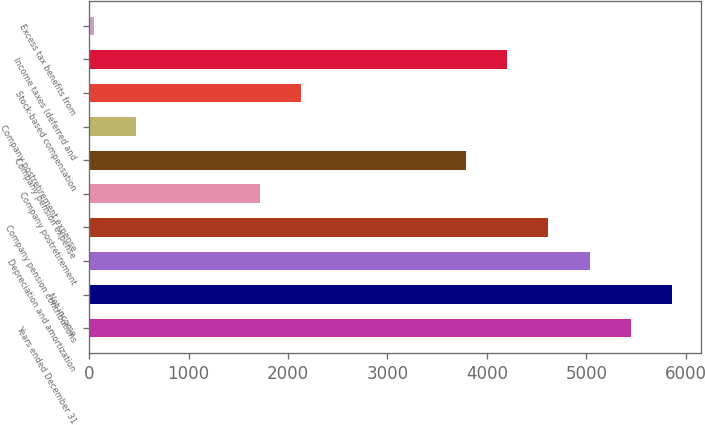Convert chart. <chart><loc_0><loc_0><loc_500><loc_500><bar_chart><fcel>Years ended December 31<fcel>Net income<fcel>Depreciation and amortization<fcel>Company pension contributions<fcel>Company postretirement<fcel>Company pension expense<fcel>Company postretirement expense<fcel>Stock-based compensation<fcel>Income taxes (deferred and<fcel>Excess tax benefits from<nl><fcel>5449<fcel>5864<fcel>5034<fcel>4619<fcel>1714<fcel>3789<fcel>469<fcel>2129<fcel>4204<fcel>54<nl></chart> 